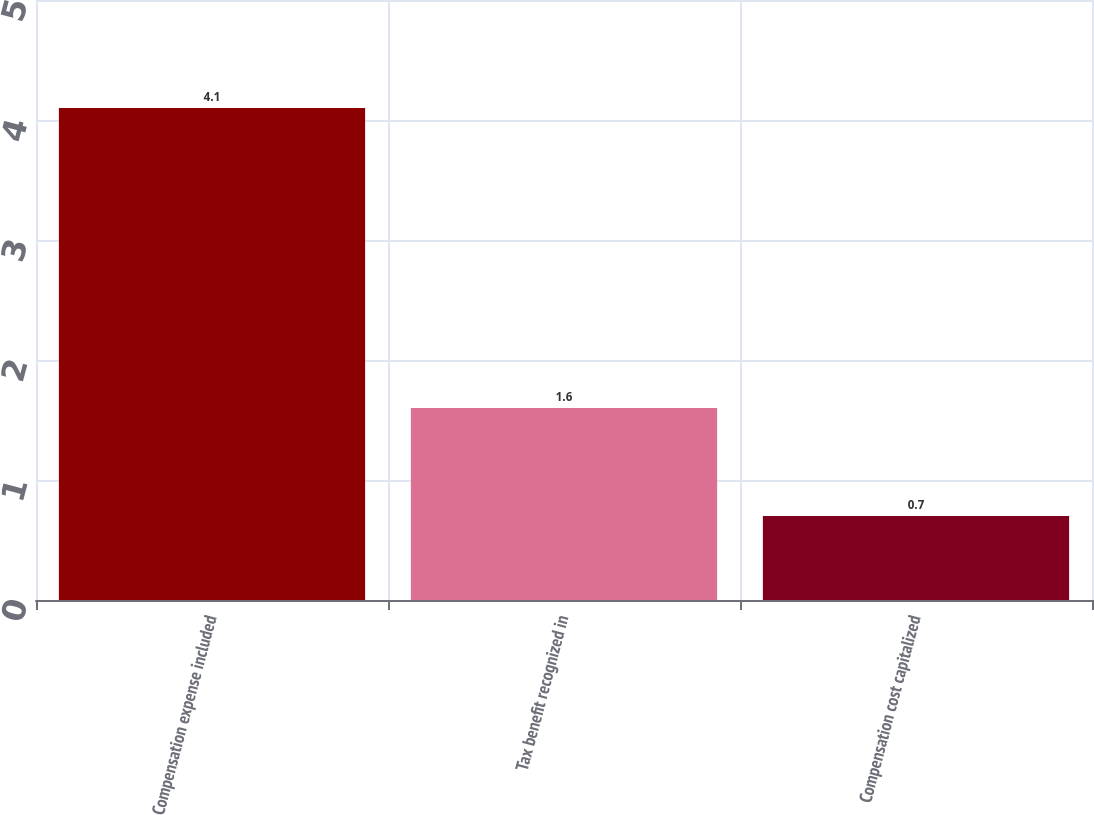Convert chart. <chart><loc_0><loc_0><loc_500><loc_500><bar_chart><fcel>Compensation expense included<fcel>Tax benefit recognized in<fcel>Compensation cost capitalized<nl><fcel>4.1<fcel>1.6<fcel>0.7<nl></chart> 